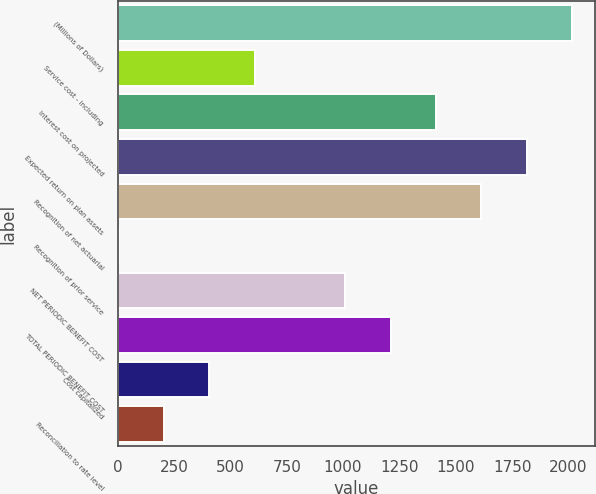Convert chart. <chart><loc_0><loc_0><loc_500><loc_500><bar_chart><fcel>(Millions of Dollars)<fcel>Service cost - including<fcel>Interest cost on projected<fcel>Expected return on plan assets<fcel>Recognition of net actuarial<fcel>Recognition of prior service<fcel>NET PERIODIC BENEFIT COST<fcel>TOTAL PERIODIC BENEFIT COST<fcel>Cost capitalized<fcel>Reconciliation to rate level<nl><fcel>2016<fcel>607.6<fcel>1412.4<fcel>1814.8<fcel>1613.6<fcel>4<fcel>1010<fcel>1211.2<fcel>406.4<fcel>205.2<nl></chart> 